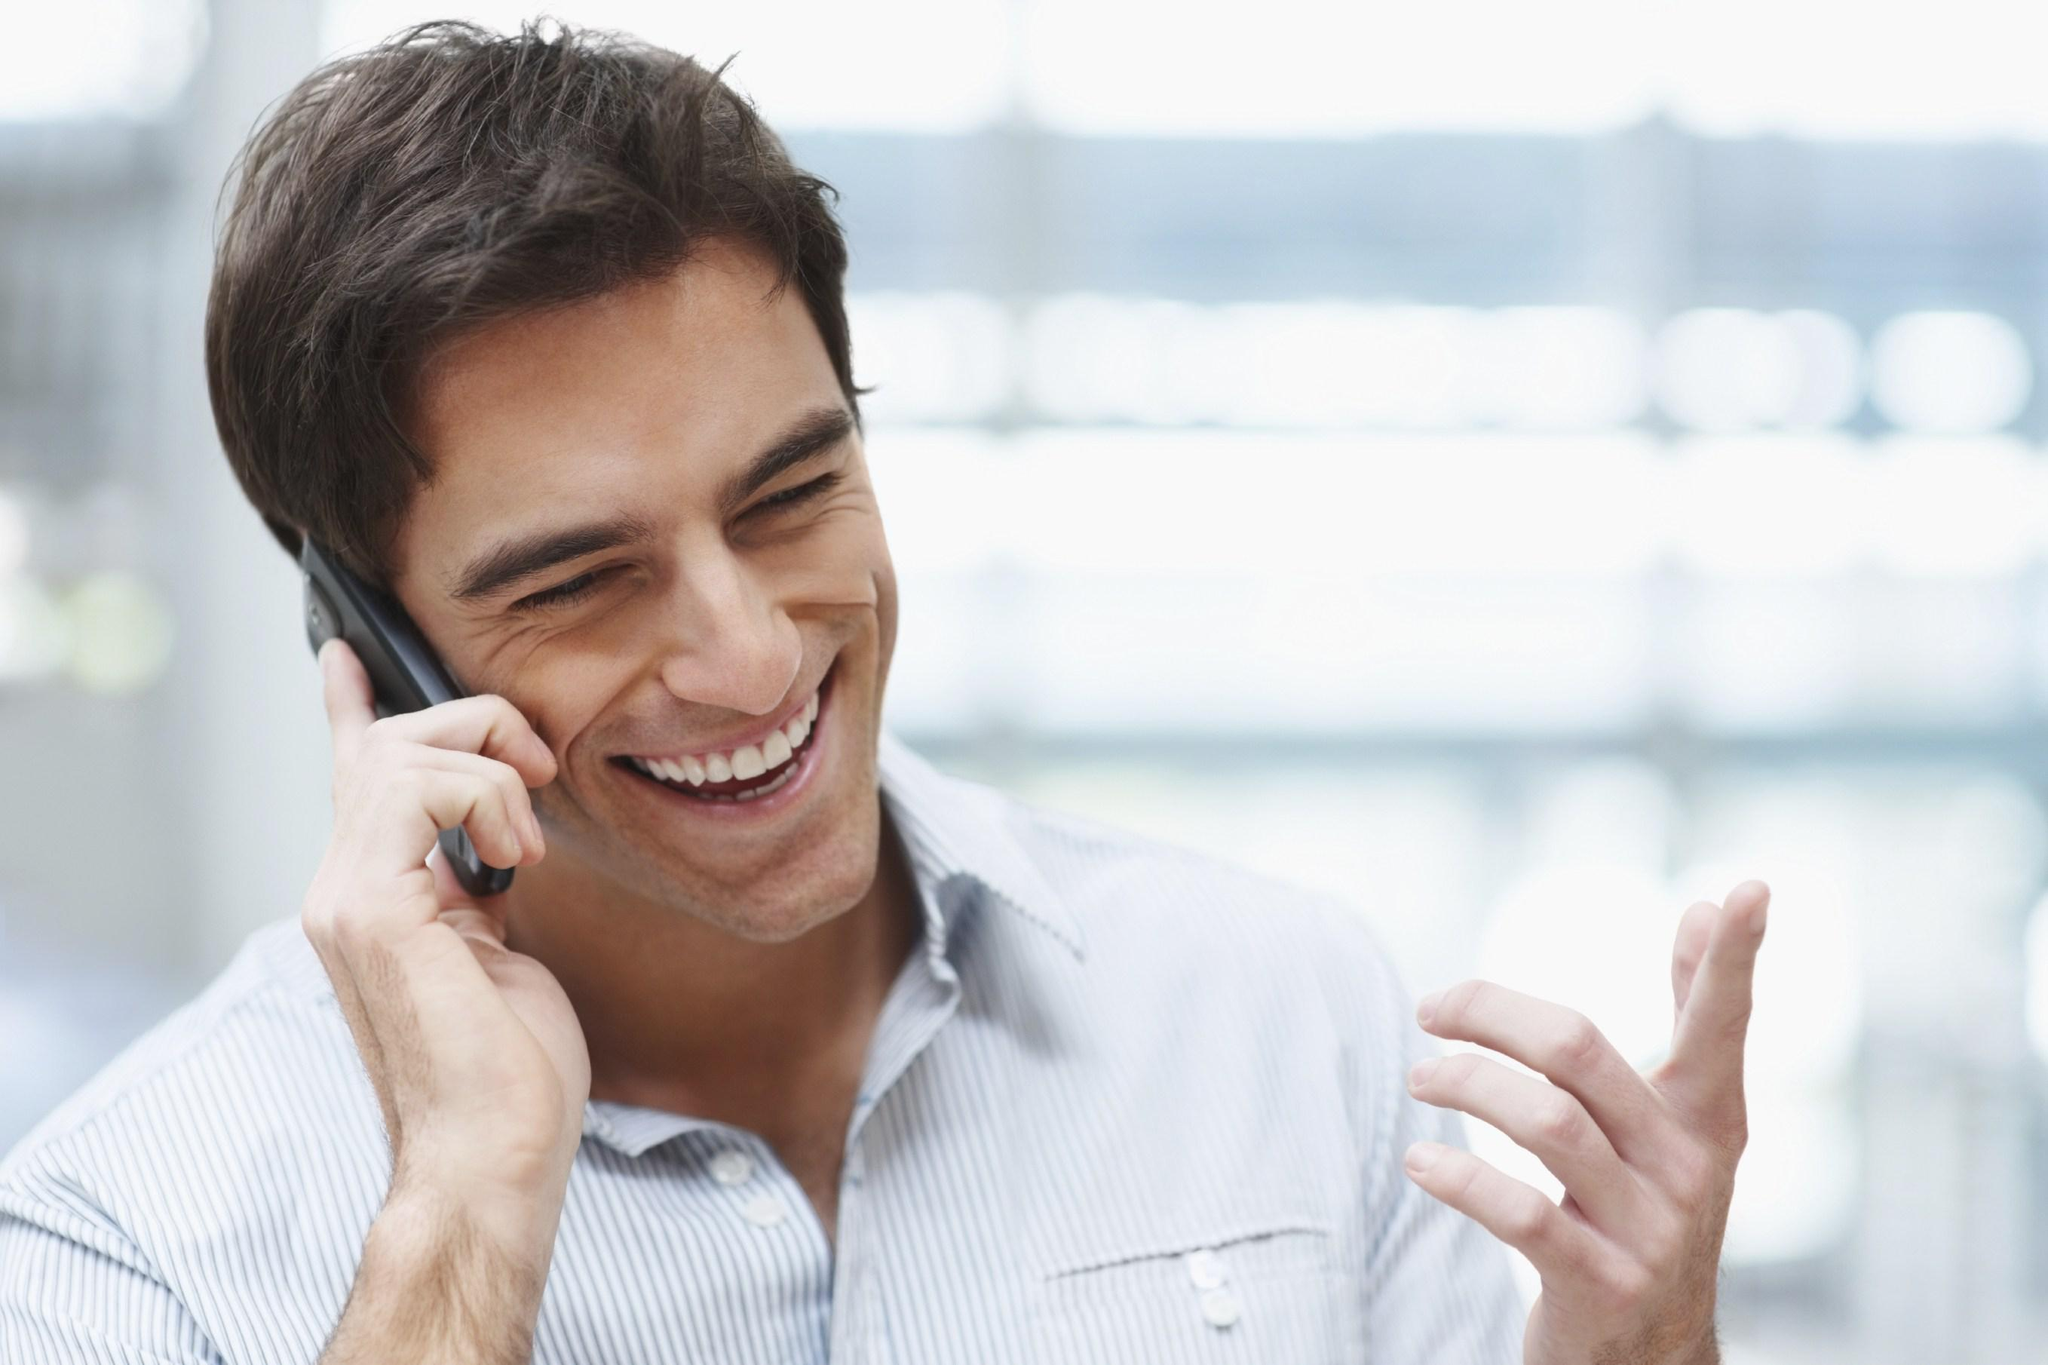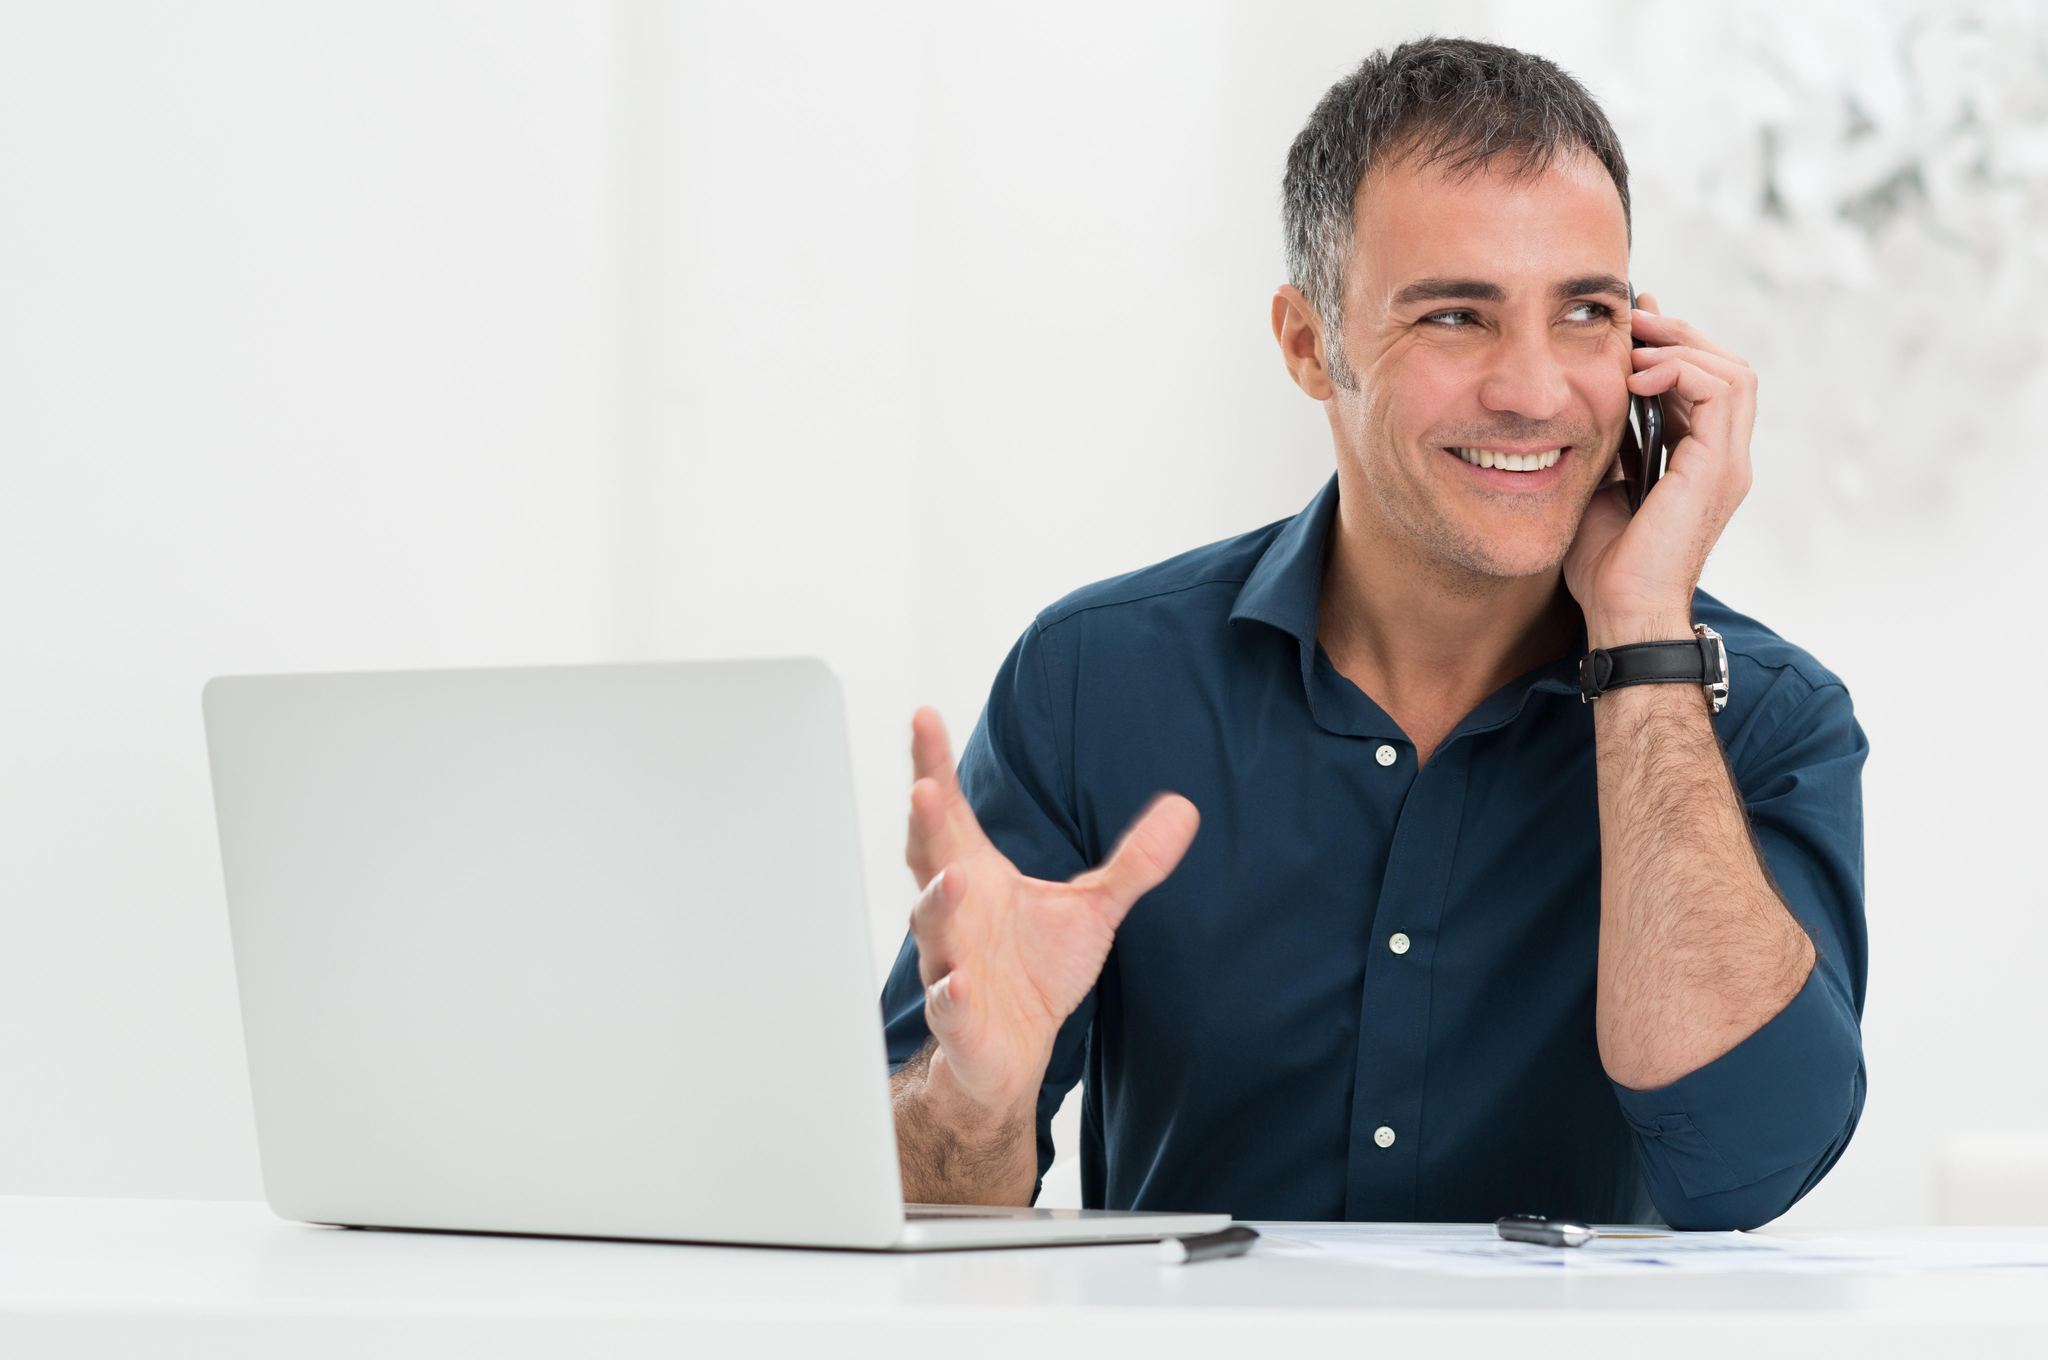The first image is the image on the left, the second image is the image on the right. Evaluate the accuracy of this statement regarding the images: "The left and right image contains the same number of men.". Is it true? Answer yes or no. Yes. 